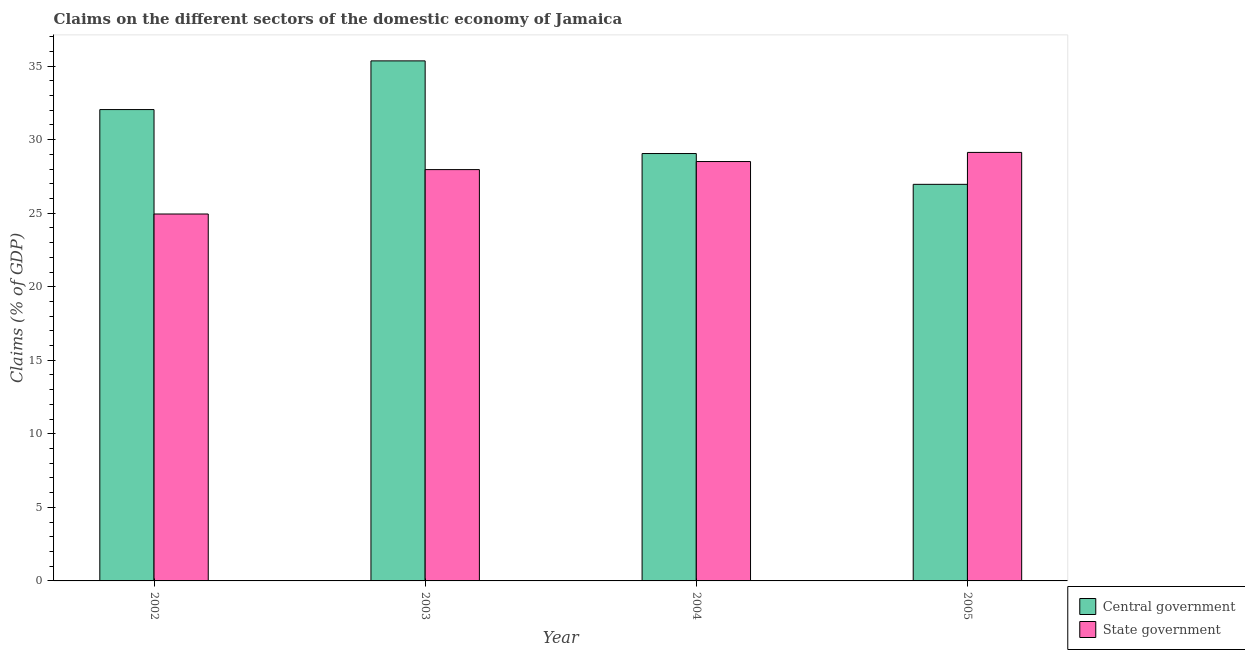How many different coloured bars are there?
Provide a succinct answer. 2. How many bars are there on the 4th tick from the left?
Offer a terse response. 2. How many bars are there on the 3rd tick from the right?
Make the answer very short. 2. In how many cases, is the number of bars for a given year not equal to the number of legend labels?
Your response must be concise. 0. What is the claims on state government in 2003?
Offer a terse response. 27.96. Across all years, what is the maximum claims on state government?
Your answer should be very brief. 29.13. Across all years, what is the minimum claims on state government?
Provide a short and direct response. 24.95. In which year was the claims on central government maximum?
Your response must be concise. 2003. What is the total claims on central government in the graph?
Keep it short and to the point. 123.42. What is the difference between the claims on central government in 2003 and that in 2004?
Make the answer very short. 6.3. What is the difference between the claims on central government in 2005 and the claims on state government in 2002?
Ensure brevity in your answer.  -5.08. What is the average claims on central government per year?
Give a very brief answer. 30.86. In the year 2002, what is the difference between the claims on state government and claims on central government?
Ensure brevity in your answer.  0. In how many years, is the claims on state government greater than 18 %?
Provide a succinct answer. 4. What is the ratio of the claims on state government in 2002 to that in 2004?
Offer a terse response. 0.87. Is the difference between the claims on central government in 2004 and 2005 greater than the difference between the claims on state government in 2004 and 2005?
Provide a succinct answer. No. What is the difference between the highest and the second highest claims on central government?
Ensure brevity in your answer.  3.31. What is the difference between the highest and the lowest claims on central government?
Give a very brief answer. 8.39. In how many years, is the claims on central government greater than the average claims on central government taken over all years?
Keep it short and to the point. 2. What does the 2nd bar from the left in 2002 represents?
Your response must be concise. State government. What does the 2nd bar from the right in 2003 represents?
Your answer should be compact. Central government. How many bars are there?
Your answer should be compact. 8. Are all the bars in the graph horizontal?
Ensure brevity in your answer.  No. How many years are there in the graph?
Your answer should be very brief. 4. Where does the legend appear in the graph?
Your answer should be compact. Bottom right. How many legend labels are there?
Provide a succinct answer. 2. How are the legend labels stacked?
Offer a very short reply. Vertical. What is the title of the graph?
Offer a very short reply. Claims on the different sectors of the domestic economy of Jamaica. Does "Measles" appear as one of the legend labels in the graph?
Your answer should be very brief. No. What is the label or title of the Y-axis?
Ensure brevity in your answer.  Claims (% of GDP). What is the Claims (% of GDP) of Central government in 2002?
Your answer should be compact. 32.05. What is the Claims (% of GDP) in State government in 2002?
Your answer should be compact. 24.95. What is the Claims (% of GDP) in Central government in 2003?
Provide a succinct answer. 35.36. What is the Claims (% of GDP) of State government in 2003?
Offer a very short reply. 27.96. What is the Claims (% of GDP) of Central government in 2004?
Ensure brevity in your answer.  29.06. What is the Claims (% of GDP) of State government in 2004?
Offer a terse response. 28.51. What is the Claims (% of GDP) of Central government in 2005?
Ensure brevity in your answer.  26.96. What is the Claims (% of GDP) of State government in 2005?
Offer a very short reply. 29.13. Across all years, what is the maximum Claims (% of GDP) in Central government?
Give a very brief answer. 35.36. Across all years, what is the maximum Claims (% of GDP) in State government?
Make the answer very short. 29.13. Across all years, what is the minimum Claims (% of GDP) in Central government?
Make the answer very short. 26.96. Across all years, what is the minimum Claims (% of GDP) in State government?
Offer a terse response. 24.95. What is the total Claims (% of GDP) in Central government in the graph?
Your answer should be compact. 123.42. What is the total Claims (% of GDP) in State government in the graph?
Offer a very short reply. 110.56. What is the difference between the Claims (% of GDP) of Central government in 2002 and that in 2003?
Keep it short and to the point. -3.31. What is the difference between the Claims (% of GDP) of State government in 2002 and that in 2003?
Give a very brief answer. -3.02. What is the difference between the Claims (% of GDP) in Central government in 2002 and that in 2004?
Provide a succinct answer. 2.99. What is the difference between the Claims (% of GDP) of State government in 2002 and that in 2004?
Provide a short and direct response. -3.57. What is the difference between the Claims (% of GDP) of Central government in 2002 and that in 2005?
Make the answer very short. 5.08. What is the difference between the Claims (% of GDP) in State government in 2002 and that in 2005?
Offer a terse response. -4.19. What is the difference between the Claims (% of GDP) of Central government in 2003 and that in 2004?
Your response must be concise. 6.3. What is the difference between the Claims (% of GDP) of State government in 2003 and that in 2004?
Offer a very short reply. -0.55. What is the difference between the Claims (% of GDP) in Central government in 2003 and that in 2005?
Provide a short and direct response. 8.39. What is the difference between the Claims (% of GDP) in State government in 2003 and that in 2005?
Provide a short and direct response. -1.17. What is the difference between the Claims (% of GDP) in Central government in 2004 and that in 2005?
Provide a short and direct response. 2.09. What is the difference between the Claims (% of GDP) in State government in 2004 and that in 2005?
Give a very brief answer. -0.62. What is the difference between the Claims (% of GDP) of Central government in 2002 and the Claims (% of GDP) of State government in 2003?
Your answer should be compact. 4.08. What is the difference between the Claims (% of GDP) of Central government in 2002 and the Claims (% of GDP) of State government in 2004?
Offer a terse response. 3.53. What is the difference between the Claims (% of GDP) of Central government in 2002 and the Claims (% of GDP) of State government in 2005?
Offer a terse response. 2.91. What is the difference between the Claims (% of GDP) in Central government in 2003 and the Claims (% of GDP) in State government in 2004?
Provide a succinct answer. 6.84. What is the difference between the Claims (% of GDP) of Central government in 2003 and the Claims (% of GDP) of State government in 2005?
Provide a succinct answer. 6.22. What is the difference between the Claims (% of GDP) of Central government in 2004 and the Claims (% of GDP) of State government in 2005?
Offer a terse response. -0.08. What is the average Claims (% of GDP) of Central government per year?
Provide a succinct answer. 30.86. What is the average Claims (% of GDP) of State government per year?
Provide a short and direct response. 27.64. In the year 2002, what is the difference between the Claims (% of GDP) in Central government and Claims (% of GDP) in State government?
Your answer should be compact. 7.1. In the year 2003, what is the difference between the Claims (% of GDP) of Central government and Claims (% of GDP) of State government?
Give a very brief answer. 7.39. In the year 2004, what is the difference between the Claims (% of GDP) of Central government and Claims (% of GDP) of State government?
Make the answer very short. 0.54. In the year 2005, what is the difference between the Claims (% of GDP) of Central government and Claims (% of GDP) of State government?
Your answer should be very brief. -2.17. What is the ratio of the Claims (% of GDP) in Central government in 2002 to that in 2003?
Give a very brief answer. 0.91. What is the ratio of the Claims (% of GDP) in State government in 2002 to that in 2003?
Your response must be concise. 0.89. What is the ratio of the Claims (% of GDP) in Central government in 2002 to that in 2004?
Your response must be concise. 1.1. What is the ratio of the Claims (% of GDP) in State government in 2002 to that in 2004?
Offer a very short reply. 0.87. What is the ratio of the Claims (% of GDP) in Central government in 2002 to that in 2005?
Keep it short and to the point. 1.19. What is the ratio of the Claims (% of GDP) in State government in 2002 to that in 2005?
Give a very brief answer. 0.86. What is the ratio of the Claims (% of GDP) in Central government in 2003 to that in 2004?
Give a very brief answer. 1.22. What is the ratio of the Claims (% of GDP) in State government in 2003 to that in 2004?
Ensure brevity in your answer.  0.98. What is the ratio of the Claims (% of GDP) of Central government in 2003 to that in 2005?
Your answer should be compact. 1.31. What is the ratio of the Claims (% of GDP) of State government in 2003 to that in 2005?
Offer a very short reply. 0.96. What is the ratio of the Claims (% of GDP) of Central government in 2004 to that in 2005?
Make the answer very short. 1.08. What is the ratio of the Claims (% of GDP) of State government in 2004 to that in 2005?
Your response must be concise. 0.98. What is the difference between the highest and the second highest Claims (% of GDP) of Central government?
Your answer should be very brief. 3.31. What is the difference between the highest and the second highest Claims (% of GDP) in State government?
Provide a short and direct response. 0.62. What is the difference between the highest and the lowest Claims (% of GDP) of Central government?
Your response must be concise. 8.39. What is the difference between the highest and the lowest Claims (% of GDP) in State government?
Give a very brief answer. 4.19. 